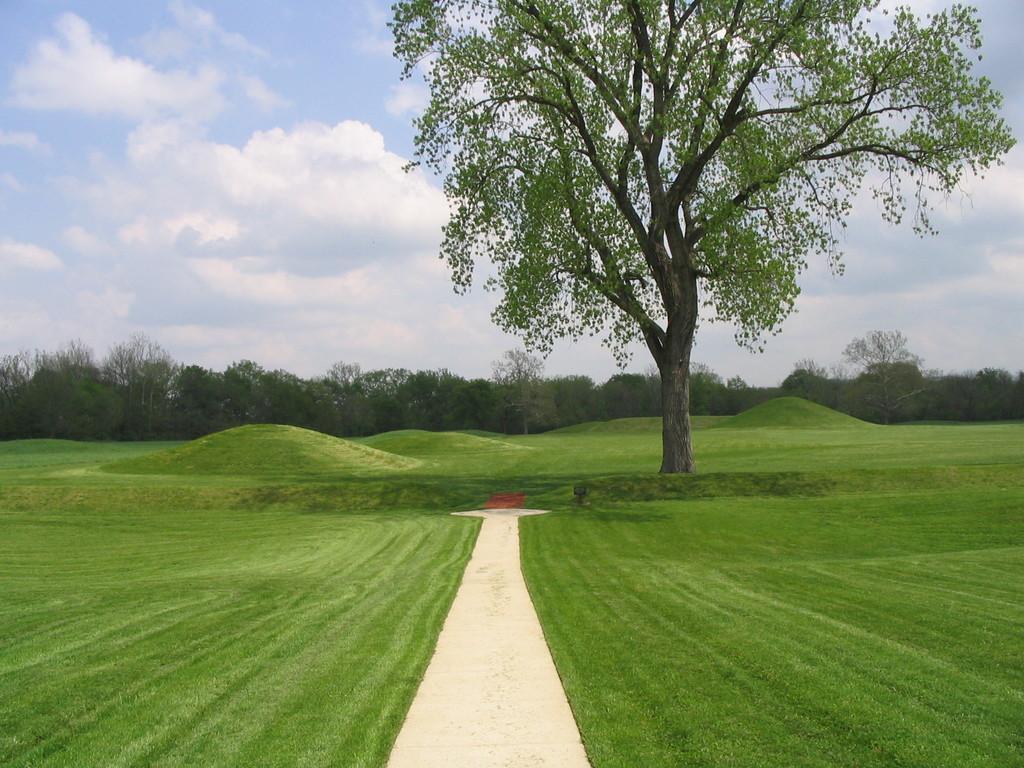Please provide a concise description of this image. At the bottom of the picture, we see the grass and the pavement. In the middle, we see a tree. There are trees in the background. At the bottom, we see the sky and the clouds. 